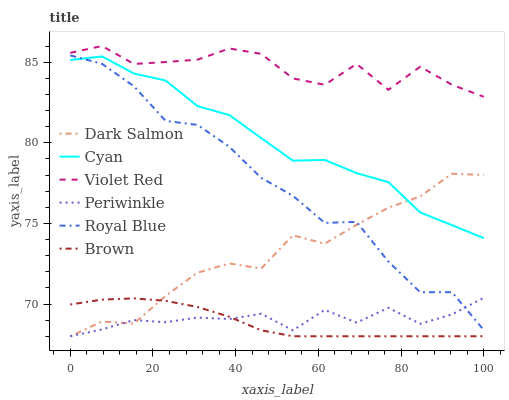Does Brown have the minimum area under the curve?
Answer yes or no. Yes. Does Dark Salmon have the minimum area under the curve?
Answer yes or no. No. Does Dark Salmon have the maximum area under the curve?
Answer yes or no. No. Is Dark Salmon the smoothest?
Answer yes or no. No. Is Dark Salmon the roughest?
Answer yes or no. No. Does Violet Red have the lowest value?
Answer yes or no. No. Does Dark Salmon have the highest value?
Answer yes or no. No. Is Dark Salmon less than Violet Red?
Answer yes or no. Yes. Is Cyan greater than Periwinkle?
Answer yes or no. Yes. Does Dark Salmon intersect Violet Red?
Answer yes or no. No. 